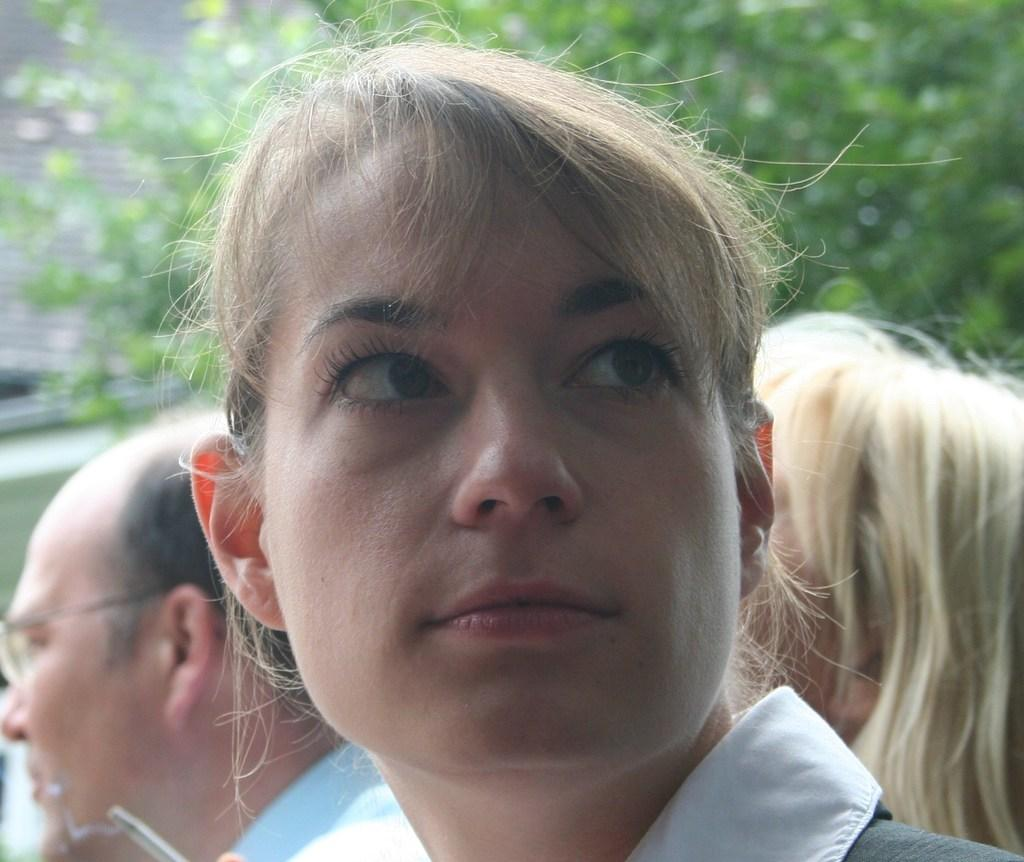How many people are in the image? There are three persons in the image. Can you describe the background of the image? The background of the image is blurred. What type of soup is being served on the road in the image? There is no road or soup present in the image. Do the persons in the image have wings? There are no wings visible on the persons in the image. 